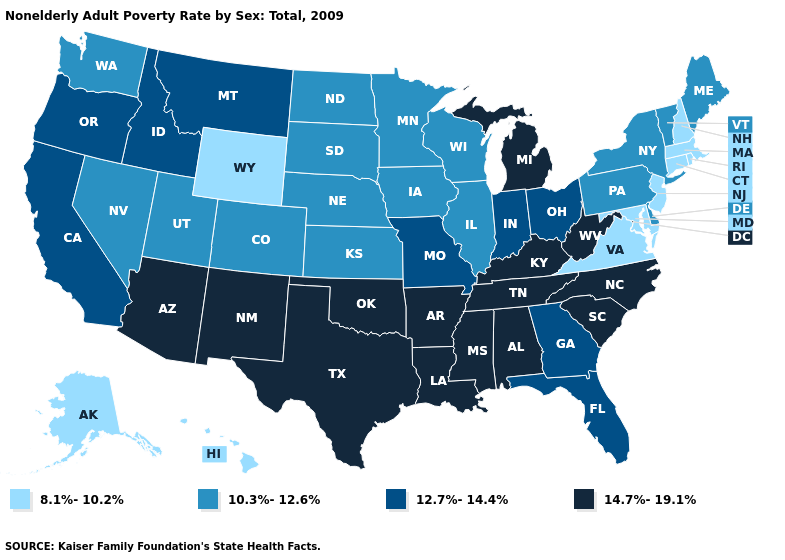Name the states that have a value in the range 8.1%-10.2%?
Give a very brief answer. Alaska, Connecticut, Hawaii, Maryland, Massachusetts, New Hampshire, New Jersey, Rhode Island, Virginia, Wyoming. What is the lowest value in the West?
Write a very short answer. 8.1%-10.2%. What is the highest value in the USA?
Keep it brief. 14.7%-19.1%. Among the states that border Indiana , does Kentucky have the highest value?
Quick response, please. Yes. Among the states that border California , does Nevada have the lowest value?
Short answer required. Yes. Name the states that have a value in the range 8.1%-10.2%?
Be succinct. Alaska, Connecticut, Hawaii, Maryland, Massachusetts, New Hampshire, New Jersey, Rhode Island, Virginia, Wyoming. What is the lowest value in the West?
Give a very brief answer. 8.1%-10.2%. Does the first symbol in the legend represent the smallest category?
Write a very short answer. Yes. Name the states that have a value in the range 10.3%-12.6%?
Write a very short answer. Colorado, Delaware, Illinois, Iowa, Kansas, Maine, Minnesota, Nebraska, Nevada, New York, North Dakota, Pennsylvania, South Dakota, Utah, Vermont, Washington, Wisconsin. Does Nebraska have a higher value than Alaska?
Quick response, please. Yes. What is the lowest value in the USA?
Answer briefly. 8.1%-10.2%. Name the states that have a value in the range 14.7%-19.1%?
Write a very short answer. Alabama, Arizona, Arkansas, Kentucky, Louisiana, Michigan, Mississippi, New Mexico, North Carolina, Oklahoma, South Carolina, Tennessee, Texas, West Virginia. Name the states that have a value in the range 14.7%-19.1%?
Write a very short answer. Alabama, Arizona, Arkansas, Kentucky, Louisiana, Michigan, Mississippi, New Mexico, North Carolina, Oklahoma, South Carolina, Tennessee, Texas, West Virginia. How many symbols are there in the legend?
Concise answer only. 4. Among the states that border Oklahoma , does Arkansas have the lowest value?
Short answer required. No. 